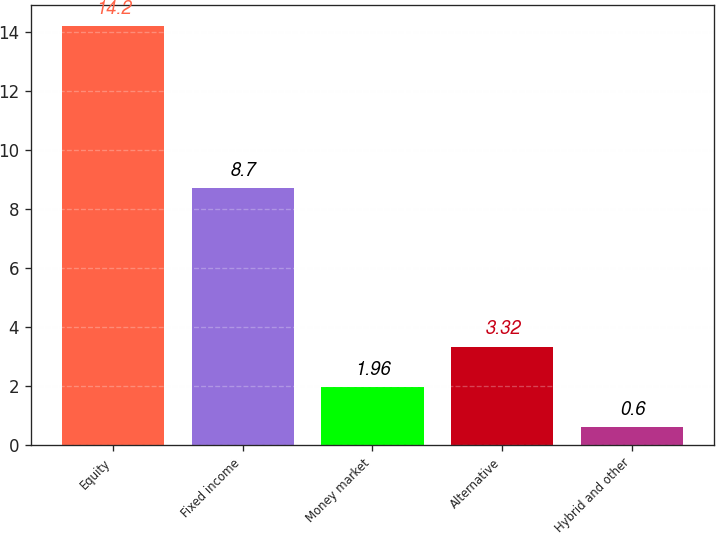Convert chart to OTSL. <chart><loc_0><loc_0><loc_500><loc_500><bar_chart><fcel>Equity<fcel>Fixed income<fcel>Money market<fcel>Alternative<fcel>Hybrid and other<nl><fcel>14.2<fcel>8.7<fcel>1.96<fcel>3.32<fcel>0.6<nl></chart> 